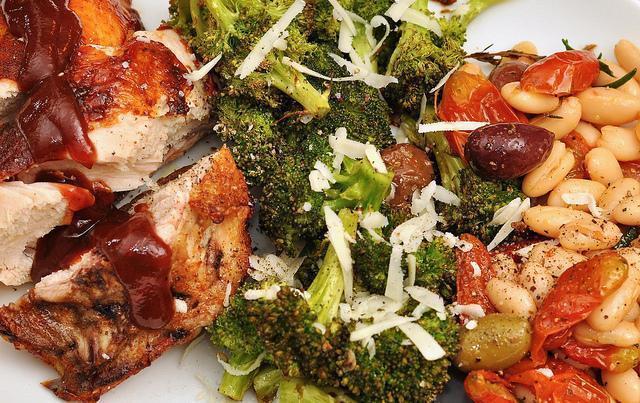How many different foods are on the plate?
Give a very brief answer. 3. How many broccolis are there?
Give a very brief answer. 9. 